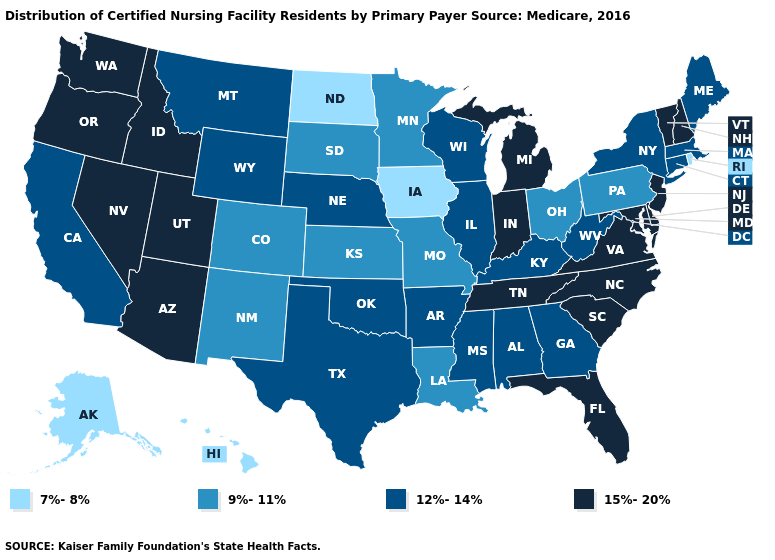Name the states that have a value in the range 12%-14%?
Short answer required. Alabama, Arkansas, California, Connecticut, Georgia, Illinois, Kentucky, Maine, Massachusetts, Mississippi, Montana, Nebraska, New York, Oklahoma, Texas, West Virginia, Wisconsin, Wyoming. Name the states that have a value in the range 15%-20%?
Concise answer only. Arizona, Delaware, Florida, Idaho, Indiana, Maryland, Michigan, Nevada, New Hampshire, New Jersey, North Carolina, Oregon, South Carolina, Tennessee, Utah, Vermont, Virginia, Washington. What is the value of Arizona?
Quick response, please. 15%-20%. What is the value of Illinois?
Keep it brief. 12%-14%. Does Connecticut have the highest value in the Northeast?
Keep it brief. No. Which states hav the highest value in the West?
Be succinct. Arizona, Idaho, Nevada, Oregon, Utah, Washington. What is the value of Utah?
Keep it brief. 15%-20%. What is the highest value in the USA?
Give a very brief answer. 15%-20%. Among the states that border West Virginia , which have the lowest value?
Concise answer only. Ohio, Pennsylvania. What is the value of Washington?
Answer briefly. 15%-20%. Which states hav the highest value in the West?
Concise answer only. Arizona, Idaho, Nevada, Oregon, Utah, Washington. Does Washington have the highest value in the USA?
Give a very brief answer. Yes. Which states hav the highest value in the Northeast?
Write a very short answer. New Hampshire, New Jersey, Vermont. What is the value of Oklahoma?
Write a very short answer. 12%-14%. 